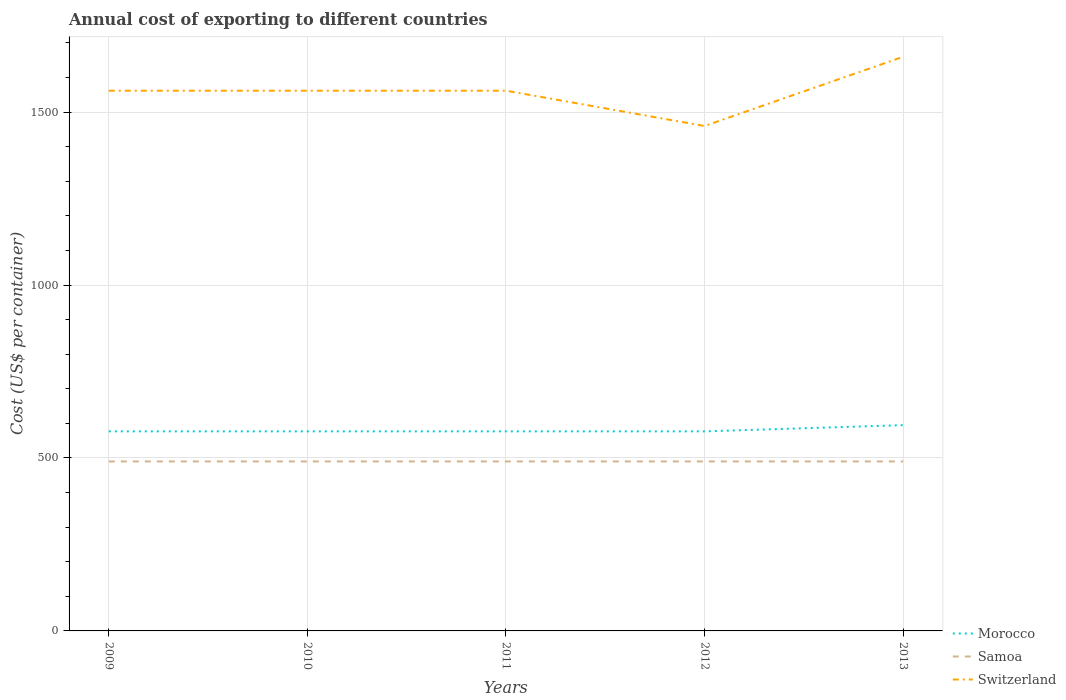How many different coloured lines are there?
Provide a succinct answer. 3. Across all years, what is the maximum total annual cost of exporting in Switzerland?
Offer a terse response. 1460. In which year was the total annual cost of exporting in Morocco maximum?
Keep it short and to the point. 2009. What is the total total annual cost of exporting in Switzerland in the graph?
Your answer should be compact. 102. What is the difference between the highest and the second highest total annual cost of exporting in Samoa?
Provide a succinct answer. 0. What is the difference between the highest and the lowest total annual cost of exporting in Morocco?
Ensure brevity in your answer.  1. Is the total annual cost of exporting in Switzerland strictly greater than the total annual cost of exporting in Samoa over the years?
Offer a terse response. No. What is the difference between two consecutive major ticks on the Y-axis?
Keep it short and to the point. 500. Does the graph contain any zero values?
Give a very brief answer. No. Where does the legend appear in the graph?
Your response must be concise. Bottom right. How are the legend labels stacked?
Offer a terse response. Vertical. What is the title of the graph?
Offer a very short reply. Annual cost of exporting to different countries. What is the label or title of the X-axis?
Provide a short and direct response. Years. What is the label or title of the Y-axis?
Give a very brief answer. Cost (US$ per container). What is the Cost (US$ per container) of Morocco in 2009?
Your answer should be compact. 577. What is the Cost (US$ per container) in Samoa in 2009?
Your answer should be compact. 490. What is the Cost (US$ per container) in Switzerland in 2009?
Make the answer very short. 1562. What is the Cost (US$ per container) of Morocco in 2010?
Make the answer very short. 577. What is the Cost (US$ per container) of Samoa in 2010?
Offer a terse response. 490. What is the Cost (US$ per container) of Switzerland in 2010?
Ensure brevity in your answer.  1562. What is the Cost (US$ per container) of Morocco in 2011?
Your answer should be compact. 577. What is the Cost (US$ per container) in Samoa in 2011?
Give a very brief answer. 490. What is the Cost (US$ per container) in Switzerland in 2011?
Offer a very short reply. 1562. What is the Cost (US$ per container) of Morocco in 2012?
Provide a succinct answer. 577. What is the Cost (US$ per container) in Samoa in 2012?
Provide a short and direct response. 490. What is the Cost (US$ per container) of Switzerland in 2012?
Provide a short and direct response. 1460. What is the Cost (US$ per container) in Morocco in 2013?
Make the answer very short. 595. What is the Cost (US$ per container) of Samoa in 2013?
Your answer should be compact. 490. What is the Cost (US$ per container) in Switzerland in 2013?
Give a very brief answer. 1660. Across all years, what is the maximum Cost (US$ per container) in Morocco?
Provide a short and direct response. 595. Across all years, what is the maximum Cost (US$ per container) of Samoa?
Offer a terse response. 490. Across all years, what is the maximum Cost (US$ per container) in Switzerland?
Keep it short and to the point. 1660. Across all years, what is the minimum Cost (US$ per container) of Morocco?
Ensure brevity in your answer.  577. Across all years, what is the minimum Cost (US$ per container) of Samoa?
Provide a succinct answer. 490. Across all years, what is the minimum Cost (US$ per container) in Switzerland?
Offer a terse response. 1460. What is the total Cost (US$ per container) of Morocco in the graph?
Your answer should be very brief. 2903. What is the total Cost (US$ per container) in Samoa in the graph?
Provide a short and direct response. 2450. What is the total Cost (US$ per container) of Switzerland in the graph?
Offer a very short reply. 7806. What is the difference between the Cost (US$ per container) in Morocco in 2009 and that in 2010?
Make the answer very short. 0. What is the difference between the Cost (US$ per container) of Morocco in 2009 and that in 2011?
Your response must be concise. 0. What is the difference between the Cost (US$ per container) in Switzerland in 2009 and that in 2011?
Your answer should be very brief. 0. What is the difference between the Cost (US$ per container) of Morocco in 2009 and that in 2012?
Keep it short and to the point. 0. What is the difference between the Cost (US$ per container) of Switzerland in 2009 and that in 2012?
Make the answer very short. 102. What is the difference between the Cost (US$ per container) of Samoa in 2009 and that in 2013?
Provide a short and direct response. 0. What is the difference between the Cost (US$ per container) in Switzerland in 2009 and that in 2013?
Provide a short and direct response. -98. What is the difference between the Cost (US$ per container) of Morocco in 2010 and that in 2011?
Your response must be concise. 0. What is the difference between the Cost (US$ per container) of Morocco in 2010 and that in 2012?
Provide a short and direct response. 0. What is the difference between the Cost (US$ per container) of Switzerland in 2010 and that in 2012?
Ensure brevity in your answer.  102. What is the difference between the Cost (US$ per container) of Morocco in 2010 and that in 2013?
Your answer should be compact. -18. What is the difference between the Cost (US$ per container) of Switzerland in 2010 and that in 2013?
Offer a terse response. -98. What is the difference between the Cost (US$ per container) in Switzerland in 2011 and that in 2012?
Offer a terse response. 102. What is the difference between the Cost (US$ per container) in Switzerland in 2011 and that in 2013?
Your answer should be compact. -98. What is the difference between the Cost (US$ per container) of Switzerland in 2012 and that in 2013?
Provide a succinct answer. -200. What is the difference between the Cost (US$ per container) in Morocco in 2009 and the Cost (US$ per container) in Samoa in 2010?
Make the answer very short. 87. What is the difference between the Cost (US$ per container) in Morocco in 2009 and the Cost (US$ per container) in Switzerland in 2010?
Your answer should be very brief. -985. What is the difference between the Cost (US$ per container) of Samoa in 2009 and the Cost (US$ per container) of Switzerland in 2010?
Provide a succinct answer. -1072. What is the difference between the Cost (US$ per container) in Morocco in 2009 and the Cost (US$ per container) in Switzerland in 2011?
Provide a short and direct response. -985. What is the difference between the Cost (US$ per container) in Samoa in 2009 and the Cost (US$ per container) in Switzerland in 2011?
Your response must be concise. -1072. What is the difference between the Cost (US$ per container) of Morocco in 2009 and the Cost (US$ per container) of Switzerland in 2012?
Give a very brief answer. -883. What is the difference between the Cost (US$ per container) of Samoa in 2009 and the Cost (US$ per container) of Switzerland in 2012?
Keep it short and to the point. -970. What is the difference between the Cost (US$ per container) of Morocco in 2009 and the Cost (US$ per container) of Switzerland in 2013?
Your answer should be compact. -1083. What is the difference between the Cost (US$ per container) of Samoa in 2009 and the Cost (US$ per container) of Switzerland in 2013?
Keep it short and to the point. -1170. What is the difference between the Cost (US$ per container) of Morocco in 2010 and the Cost (US$ per container) of Samoa in 2011?
Your answer should be compact. 87. What is the difference between the Cost (US$ per container) of Morocco in 2010 and the Cost (US$ per container) of Switzerland in 2011?
Your answer should be compact. -985. What is the difference between the Cost (US$ per container) in Samoa in 2010 and the Cost (US$ per container) in Switzerland in 2011?
Make the answer very short. -1072. What is the difference between the Cost (US$ per container) in Morocco in 2010 and the Cost (US$ per container) in Switzerland in 2012?
Your answer should be very brief. -883. What is the difference between the Cost (US$ per container) of Samoa in 2010 and the Cost (US$ per container) of Switzerland in 2012?
Your answer should be compact. -970. What is the difference between the Cost (US$ per container) in Morocco in 2010 and the Cost (US$ per container) in Samoa in 2013?
Keep it short and to the point. 87. What is the difference between the Cost (US$ per container) of Morocco in 2010 and the Cost (US$ per container) of Switzerland in 2013?
Provide a succinct answer. -1083. What is the difference between the Cost (US$ per container) in Samoa in 2010 and the Cost (US$ per container) in Switzerland in 2013?
Your answer should be compact. -1170. What is the difference between the Cost (US$ per container) of Morocco in 2011 and the Cost (US$ per container) of Samoa in 2012?
Offer a very short reply. 87. What is the difference between the Cost (US$ per container) in Morocco in 2011 and the Cost (US$ per container) in Switzerland in 2012?
Keep it short and to the point. -883. What is the difference between the Cost (US$ per container) of Samoa in 2011 and the Cost (US$ per container) of Switzerland in 2012?
Your answer should be very brief. -970. What is the difference between the Cost (US$ per container) of Morocco in 2011 and the Cost (US$ per container) of Samoa in 2013?
Give a very brief answer. 87. What is the difference between the Cost (US$ per container) in Morocco in 2011 and the Cost (US$ per container) in Switzerland in 2013?
Your answer should be compact. -1083. What is the difference between the Cost (US$ per container) of Samoa in 2011 and the Cost (US$ per container) of Switzerland in 2013?
Make the answer very short. -1170. What is the difference between the Cost (US$ per container) in Morocco in 2012 and the Cost (US$ per container) in Switzerland in 2013?
Offer a terse response. -1083. What is the difference between the Cost (US$ per container) in Samoa in 2012 and the Cost (US$ per container) in Switzerland in 2013?
Provide a succinct answer. -1170. What is the average Cost (US$ per container) of Morocco per year?
Offer a terse response. 580.6. What is the average Cost (US$ per container) in Samoa per year?
Provide a succinct answer. 490. What is the average Cost (US$ per container) in Switzerland per year?
Provide a succinct answer. 1561.2. In the year 2009, what is the difference between the Cost (US$ per container) of Morocco and Cost (US$ per container) of Samoa?
Your answer should be compact. 87. In the year 2009, what is the difference between the Cost (US$ per container) of Morocco and Cost (US$ per container) of Switzerland?
Your answer should be compact. -985. In the year 2009, what is the difference between the Cost (US$ per container) in Samoa and Cost (US$ per container) in Switzerland?
Make the answer very short. -1072. In the year 2010, what is the difference between the Cost (US$ per container) of Morocco and Cost (US$ per container) of Samoa?
Give a very brief answer. 87. In the year 2010, what is the difference between the Cost (US$ per container) in Morocco and Cost (US$ per container) in Switzerland?
Offer a terse response. -985. In the year 2010, what is the difference between the Cost (US$ per container) of Samoa and Cost (US$ per container) of Switzerland?
Make the answer very short. -1072. In the year 2011, what is the difference between the Cost (US$ per container) of Morocco and Cost (US$ per container) of Samoa?
Your answer should be very brief. 87. In the year 2011, what is the difference between the Cost (US$ per container) in Morocco and Cost (US$ per container) in Switzerland?
Keep it short and to the point. -985. In the year 2011, what is the difference between the Cost (US$ per container) of Samoa and Cost (US$ per container) of Switzerland?
Offer a terse response. -1072. In the year 2012, what is the difference between the Cost (US$ per container) of Morocco and Cost (US$ per container) of Samoa?
Provide a short and direct response. 87. In the year 2012, what is the difference between the Cost (US$ per container) of Morocco and Cost (US$ per container) of Switzerland?
Your answer should be very brief. -883. In the year 2012, what is the difference between the Cost (US$ per container) of Samoa and Cost (US$ per container) of Switzerland?
Your response must be concise. -970. In the year 2013, what is the difference between the Cost (US$ per container) of Morocco and Cost (US$ per container) of Samoa?
Your response must be concise. 105. In the year 2013, what is the difference between the Cost (US$ per container) in Morocco and Cost (US$ per container) in Switzerland?
Make the answer very short. -1065. In the year 2013, what is the difference between the Cost (US$ per container) in Samoa and Cost (US$ per container) in Switzerland?
Your response must be concise. -1170. What is the ratio of the Cost (US$ per container) in Morocco in 2009 to that in 2010?
Offer a very short reply. 1. What is the ratio of the Cost (US$ per container) in Samoa in 2009 to that in 2010?
Your answer should be compact. 1. What is the ratio of the Cost (US$ per container) of Switzerland in 2009 to that in 2010?
Make the answer very short. 1. What is the ratio of the Cost (US$ per container) in Samoa in 2009 to that in 2011?
Offer a terse response. 1. What is the ratio of the Cost (US$ per container) in Switzerland in 2009 to that in 2011?
Offer a very short reply. 1. What is the ratio of the Cost (US$ per container) of Switzerland in 2009 to that in 2012?
Offer a terse response. 1.07. What is the ratio of the Cost (US$ per container) of Morocco in 2009 to that in 2013?
Offer a terse response. 0.97. What is the ratio of the Cost (US$ per container) of Samoa in 2009 to that in 2013?
Your answer should be compact. 1. What is the ratio of the Cost (US$ per container) in Switzerland in 2009 to that in 2013?
Ensure brevity in your answer.  0.94. What is the ratio of the Cost (US$ per container) in Samoa in 2010 to that in 2012?
Give a very brief answer. 1. What is the ratio of the Cost (US$ per container) of Switzerland in 2010 to that in 2012?
Make the answer very short. 1.07. What is the ratio of the Cost (US$ per container) in Morocco in 2010 to that in 2013?
Provide a short and direct response. 0.97. What is the ratio of the Cost (US$ per container) of Switzerland in 2010 to that in 2013?
Your response must be concise. 0.94. What is the ratio of the Cost (US$ per container) of Morocco in 2011 to that in 2012?
Provide a succinct answer. 1. What is the ratio of the Cost (US$ per container) in Samoa in 2011 to that in 2012?
Give a very brief answer. 1. What is the ratio of the Cost (US$ per container) in Switzerland in 2011 to that in 2012?
Ensure brevity in your answer.  1.07. What is the ratio of the Cost (US$ per container) in Morocco in 2011 to that in 2013?
Make the answer very short. 0.97. What is the ratio of the Cost (US$ per container) in Switzerland in 2011 to that in 2013?
Provide a succinct answer. 0.94. What is the ratio of the Cost (US$ per container) of Morocco in 2012 to that in 2013?
Your answer should be very brief. 0.97. What is the ratio of the Cost (US$ per container) of Samoa in 2012 to that in 2013?
Your answer should be very brief. 1. What is the ratio of the Cost (US$ per container) of Switzerland in 2012 to that in 2013?
Give a very brief answer. 0.88. What is the difference between the highest and the lowest Cost (US$ per container) of Morocco?
Your response must be concise. 18. What is the difference between the highest and the lowest Cost (US$ per container) in Samoa?
Your answer should be compact. 0. What is the difference between the highest and the lowest Cost (US$ per container) in Switzerland?
Make the answer very short. 200. 